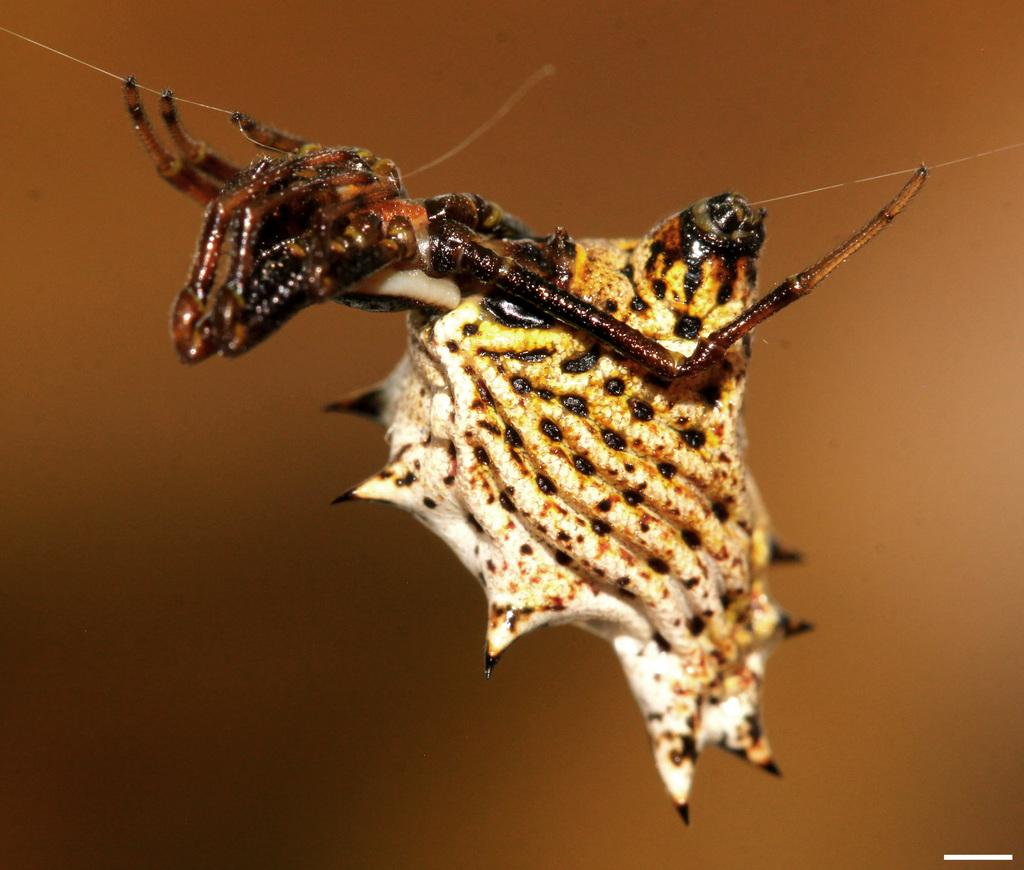What type of creature can be seen in the image? There is an insect in the image. Can you describe the background of the image? The background of the image is blurred. What color is the marble in the image? There is no marble present in the image. How does the insect sneeze in the image? Insects do not have the ability to sneeze, and there is no sneezing depicted in the image. 